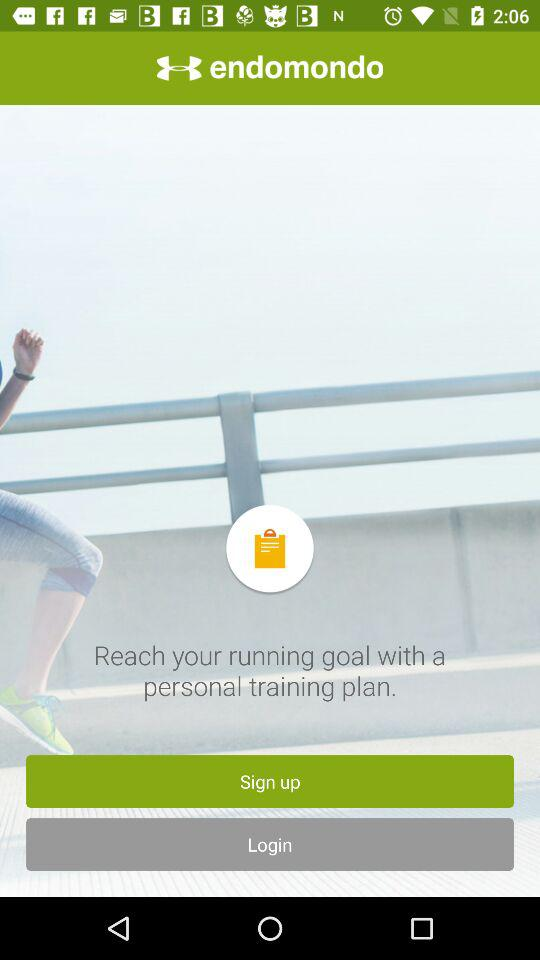What is the application name? The application name is "endomondo". 